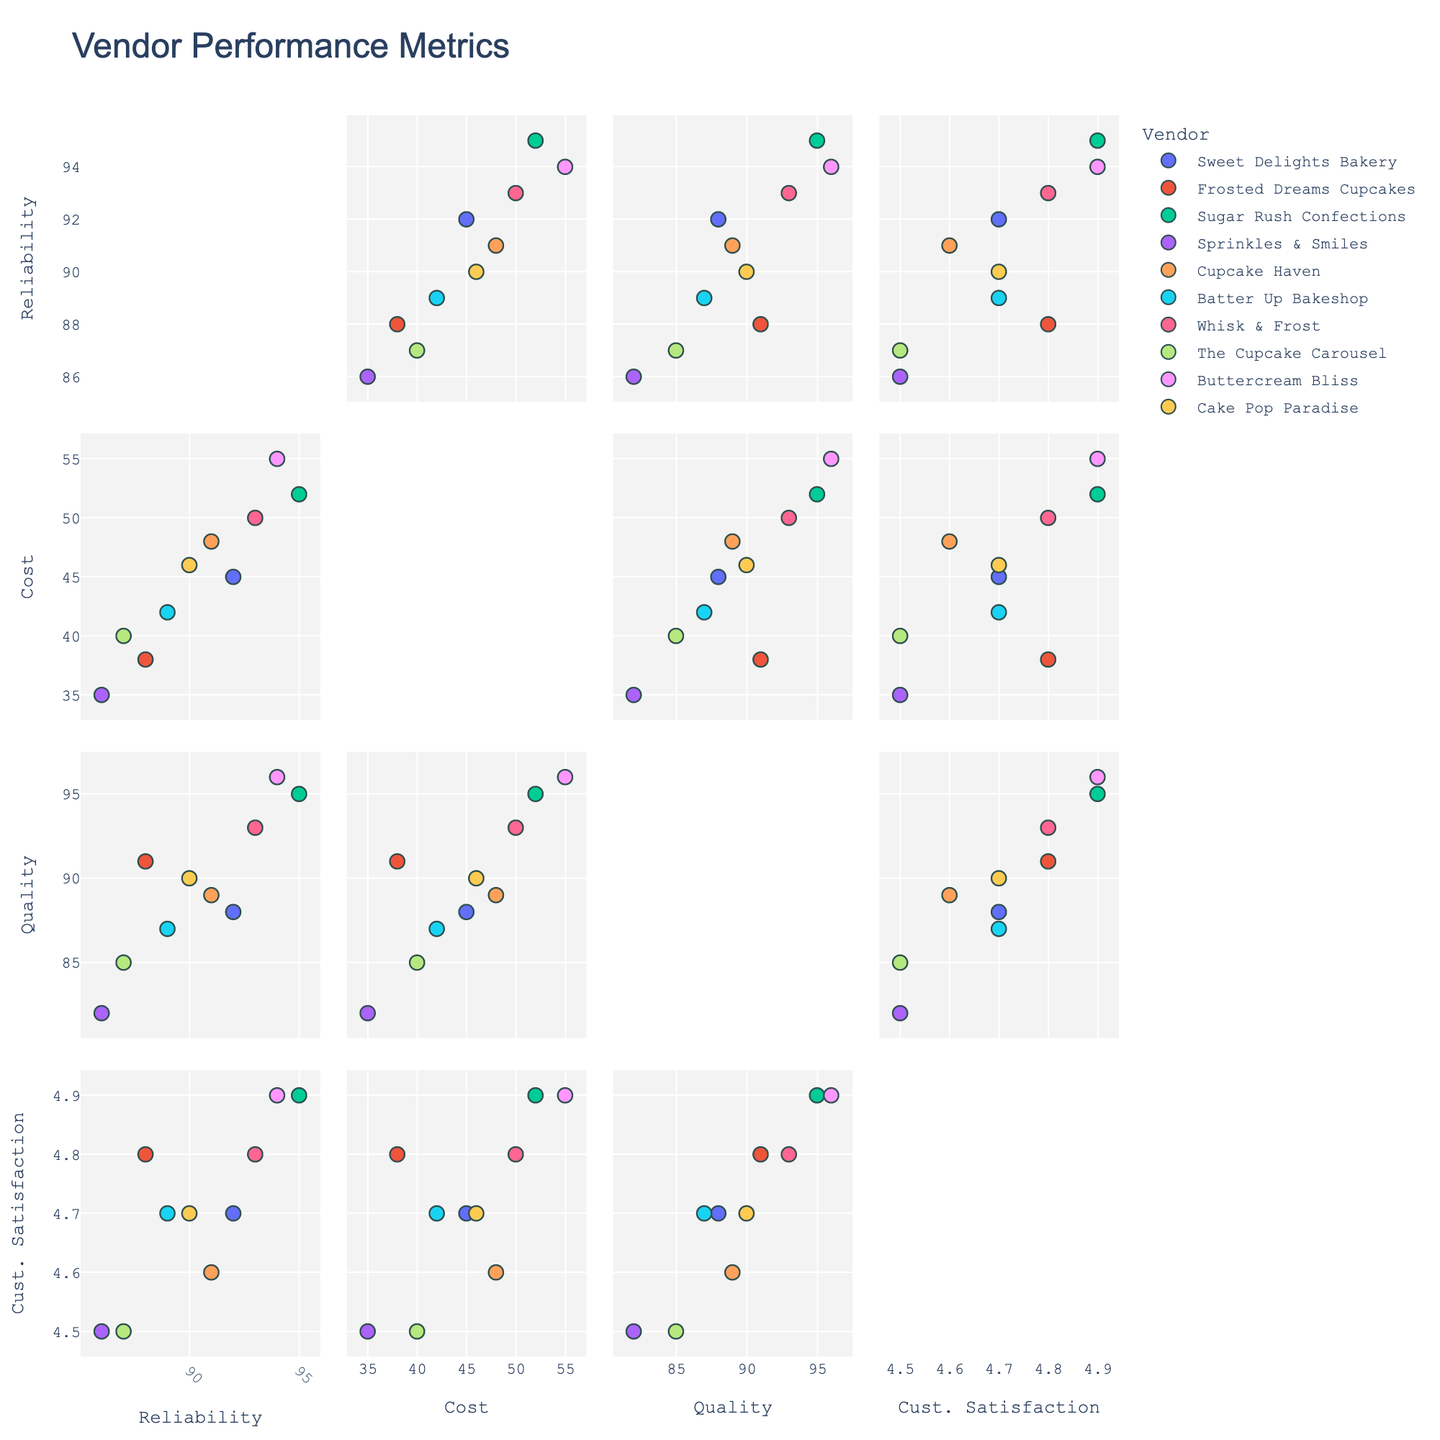What's the title of the figure? The title of a figure is usually displayed at the top, often in a larger and bold font. In this case, the specified title in the code is 'Vendor Performance Metrics'.
Answer: Vendor Performance Metrics Which vendor has the lowest cost? In the scatterplot matrix, each vendor’s cost can be identified by looking at the scatter points associated with 'Cost' on the axes. Sprinkles & Smiles has the lowest cost of 35.
Answer: Sprinkles & Smiles How does the reliability of Cupcake Haven compare to that of Frosted Dreams Cupcakes? Look for the data points corresponding to each vendor and compare their values on the reliability axis. Cupcake Haven has a reliability of 91 while Frosted Dreams Cupcakes has a reliability of 88. Therefore, Cupcake Haven is more reliable.
Answer: Cupcake Haven is more reliable Which two vendors have the highest customer satisfaction ratings? Filter the scatterplot for the highest Customer Satisfaction ratings. Both Sugar Rush Confections and Buttercream Bliss have a customer satisfaction rating of 4.9.
Answer: Sugar Rush Confections and Buttercream Bliss Is there any vendor with both high quality and high reliability? Examine the scatter points for both high quality and high reliability together. Sugar Rush Confections (95 Quality, 95 Reliability) and Buttercream Bliss (96 Quality, 94 Reliability) are both high in these metrics.
Answer: Sugar Rush Confections and Buttercream Bliss Is there a correlation between cost and quality? Observe the scatter matrix subplot that plots cost against quality. If the points show a clear pattern (increasing or decreasing together), there’s a correlation. The points seem somewhat scattered, but there is a slight positive trend indicating higher quality often comes with higher cost.
Answer: Slight positive correlation Which vendor has both the lowest reliability and lowest customer satisfaction? By identifying the lowest value on the x-axis for reliability and the y-axis for customer satisfaction, Sprinkles & Smiles can be determined as the vendor with both lowest reliability (86) and one of the lowest satisfaction values (4.5).
Answer: Sprinkles & Smiles What is the range of cost values? To determine the range, find the minimum and maximum cost values from the data points. Sprinkles & Smiles has the lowest cost at 35, and Buttercream Bliss has the highest at 55. Hence, the range is from 35 to 55.
Answer: 35 to 55 